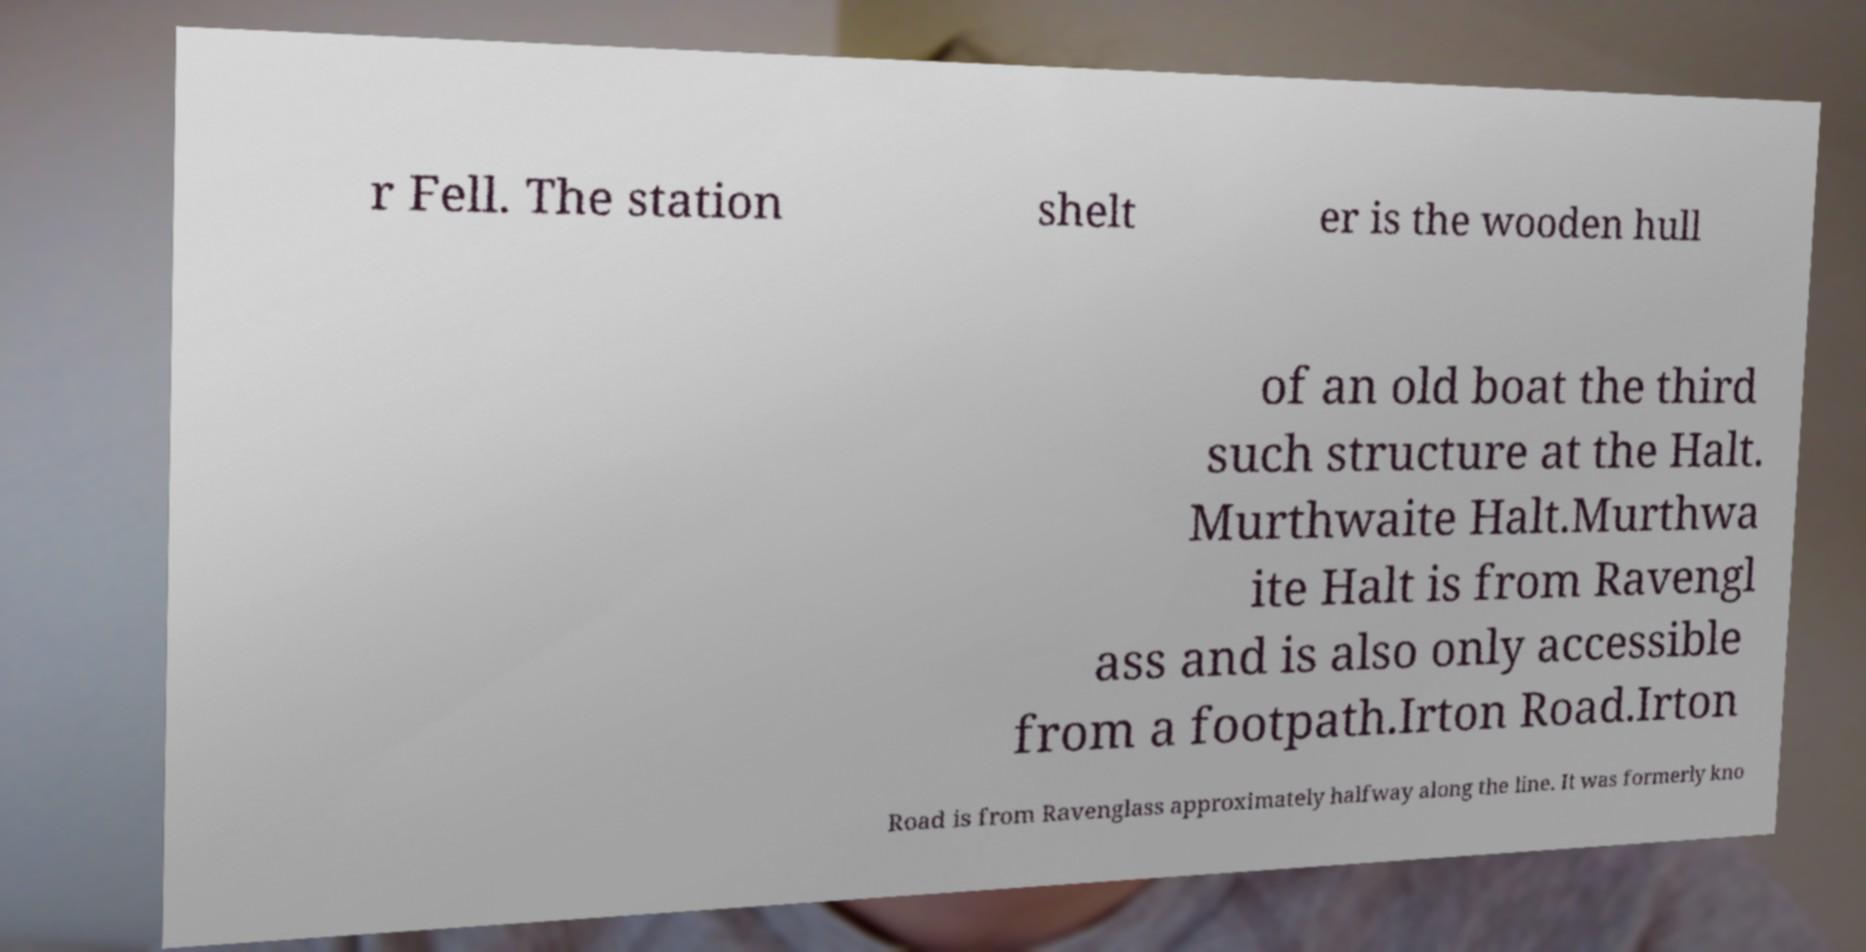What messages or text are displayed in this image? I need them in a readable, typed format. r Fell. The station shelt er is the wooden hull of an old boat the third such structure at the Halt. Murthwaite Halt.Murthwa ite Halt is from Ravengl ass and is also only accessible from a footpath.Irton Road.Irton Road is from Ravenglass approximately halfway along the line. It was formerly kno 